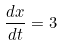Convert formula to latex. <formula><loc_0><loc_0><loc_500><loc_500>\frac { d x } { d t } = 3</formula> 